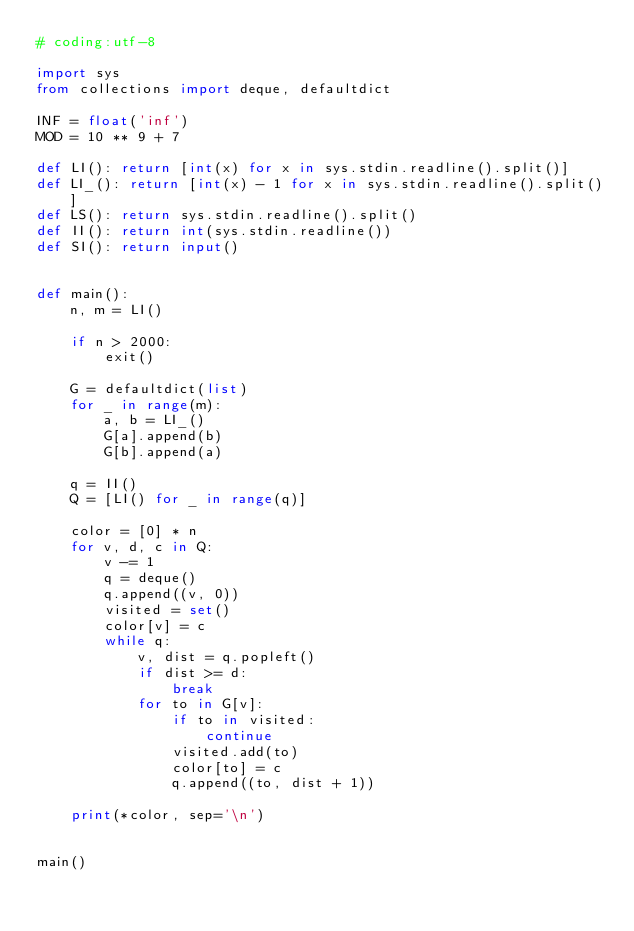<code> <loc_0><loc_0><loc_500><loc_500><_Python_># coding:utf-8

import sys
from collections import deque, defaultdict

INF = float('inf')
MOD = 10 ** 9 + 7

def LI(): return [int(x) for x in sys.stdin.readline().split()]
def LI_(): return [int(x) - 1 for x in sys.stdin.readline().split()]
def LS(): return sys.stdin.readline().split()
def II(): return int(sys.stdin.readline())
def SI(): return input()


def main():
    n, m = LI()

    if n > 2000:
        exit()

    G = defaultdict(list)
    for _ in range(m):
        a, b = LI_()
        G[a].append(b)
        G[b].append(a)

    q = II()
    Q = [LI() for _ in range(q)]

    color = [0] * n
    for v, d, c in Q:
        v -= 1
        q = deque()
        q.append((v, 0))
        visited = set()
        color[v] = c
        while q:
            v, dist = q.popleft()
            if dist >= d:
                break
            for to in G[v]:
                if to in visited:
                    continue
                visited.add(to)
                color[to] = c
                q.append((to, dist + 1))

    print(*color, sep='\n')


main()
</code> 